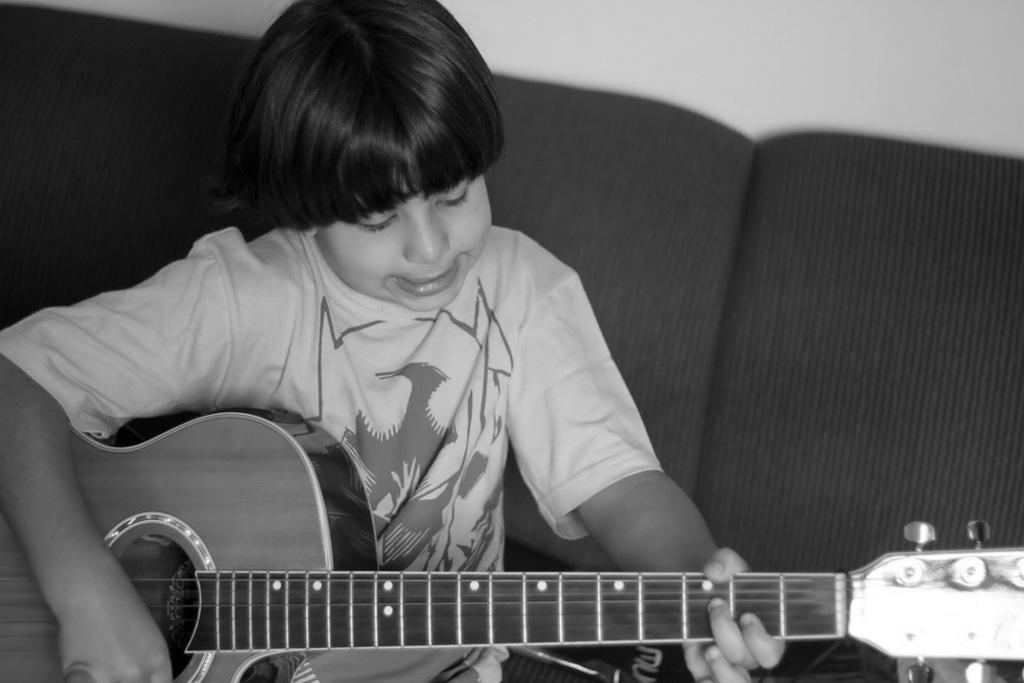Who is the main subject in the image? There is a boy in the image. What is the boy doing in the image? The boy is sitting on a couch and playing the guitar. What can be seen in the background of the image? There is a white wall in the background of the image. How many kittens are playing on the boy's lap in the image? There are no kittens present in the image. What type of operation is being performed on the guitar in the image? There is no operation being performed on the guitar in the image; the boy is simply playing it. 